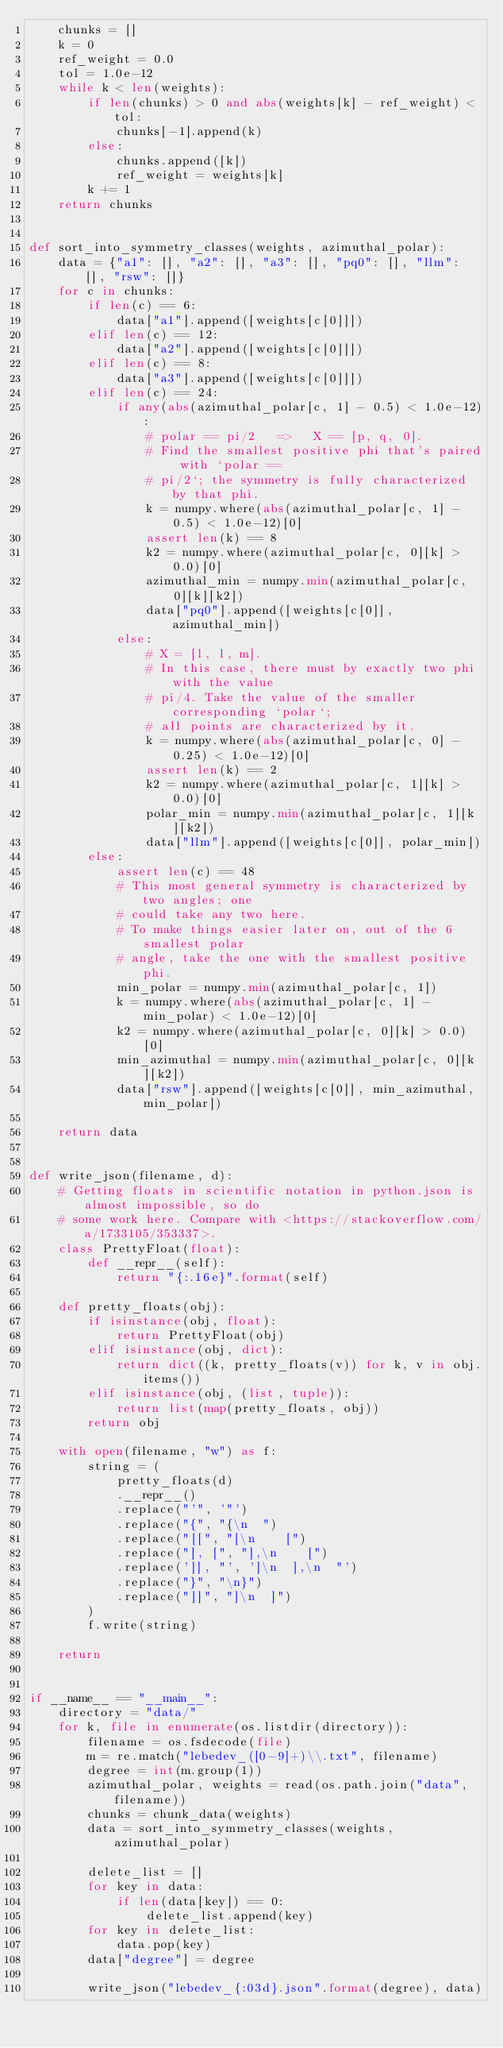<code> <loc_0><loc_0><loc_500><loc_500><_Python_>    chunks = []
    k = 0
    ref_weight = 0.0
    tol = 1.0e-12
    while k < len(weights):
        if len(chunks) > 0 and abs(weights[k] - ref_weight) < tol:
            chunks[-1].append(k)
        else:
            chunks.append([k])
            ref_weight = weights[k]
        k += 1
    return chunks


def sort_into_symmetry_classes(weights, azimuthal_polar):
    data = {"a1": [], "a2": [], "a3": [], "pq0": [], "llm": [], "rsw": []}
    for c in chunks:
        if len(c) == 6:
            data["a1"].append([weights[c[0]]])
        elif len(c) == 12:
            data["a2"].append([weights[c[0]]])
        elif len(c) == 8:
            data["a3"].append([weights[c[0]]])
        elif len(c) == 24:
            if any(abs(azimuthal_polar[c, 1] - 0.5) < 1.0e-12):
                # polar == pi/2   =>   X == [p, q, 0].
                # Find the smallest positive phi that's paired with `polar ==
                # pi/2`; the symmetry is fully characterized by that phi.
                k = numpy.where(abs(azimuthal_polar[c, 1] - 0.5) < 1.0e-12)[0]
                assert len(k) == 8
                k2 = numpy.where(azimuthal_polar[c, 0][k] > 0.0)[0]
                azimuthal_min = numpy.min(azimuthal_polar[c, 0][k][k2])
                data["pq0"].append([weights[c[0]], azimuthal_min])
            else:
                # X = [l, l, m].
                # In this case, there must by exactly two phi with the value
                # pi/4. Take the value of the smaller corresponding `polar`;
                # all points are characterized by it.
                k = numpy.where(abs(azimuthal_polar[c, 0] - 0.25) < 1.0e-12)[0]
                assert len(k) == 2
                k2 = numpy.where(azimuthal_polar[c, 1][k] > 0.0)[0]
                polar_min = numpy.min(azimuthal_polar[c, 1][k][k2])
                data["llm"].append([weights[c[0]], polar_min])
        else:
            assert len(c) == 48
            # This most general symmetry is characterized by two angles; one
            # could take any two here.
            # To make things easier later on, out of the 6 smallest polar
            # angle, take the one with the smallest positive phi.
            min_polar = numpy.min(azimuthal_polar[c, 1])
            k = numpy.where(abs(azimuthal_polar[c, 1] - min_polar) < 1.0e-12)[0]
            k2 = numpy.where(azimuthal_polar[c, 0][k] > 0.0)[0]
            min_azimuthal = numpy.min(azimuthal_polar[c, 0][k][k2])
            data["rsw"].append([weights[c[0]], min_azimuthal, min_polar])

    return data


def write_json(filename, d):
    # Getting floats in scientific notation in python.json is almost impossible, so do
    # some work here. Compare with <https://stackoverflow.com/a/1733105/353337>.
    class PrettyFloat(float):
        def __repr__(self):
            return "{:.16e}".format(self)

    def pretty_floats(obj):
        if isinstance(obj, float):
            return PrettyFloat(obj)
        elif isinstance(obj, dict):
            return dict((k, pretty_floats(v)) for k, v in obj.items())
        elif isinstance(obj, (list, tuple)):
            return list(map(pretty_floats, obj))
        return obj

    with open(filename, "w") as f:
        string = (
            pretty_floats(d)
            .__repr__()
            .replace("'", '"')
            .replace("{", "{\n  ")
            .replace("[[", "[\n    [")
            .replace("], [", "],\n    [")
            .replace(']], "', ']\n  ],\n  "')
            .replace("}", "\n}")
            .replace("]]", "]\n  ]")
        )
        f.write(string)

    return


if __name__ == "__main__":
    directory = "data/"
    for k, file in enumerate(os.listdir(directory)):
        filename = os.fsdecode(file)
        m = re.match("lebedev_([0-9]+)\\.txt", filename)
        degree = int(m.group(1))
        azimuthal_polar, weights = read(os.path.join("data", filename))
        chunks = chunk_data(weights)
        data = sort_into_symmetry_classes(weights, azimuthal_polar)

        delete_list = []
        for key in data:
            if len(data[key]) == 0:
                delete_list.append(key)
        for key in delete_list:
            data.pop(key)
        data["degree"] = degree

        write_json("lebedev_{:03d}.json".format(degree), data)
</code> 